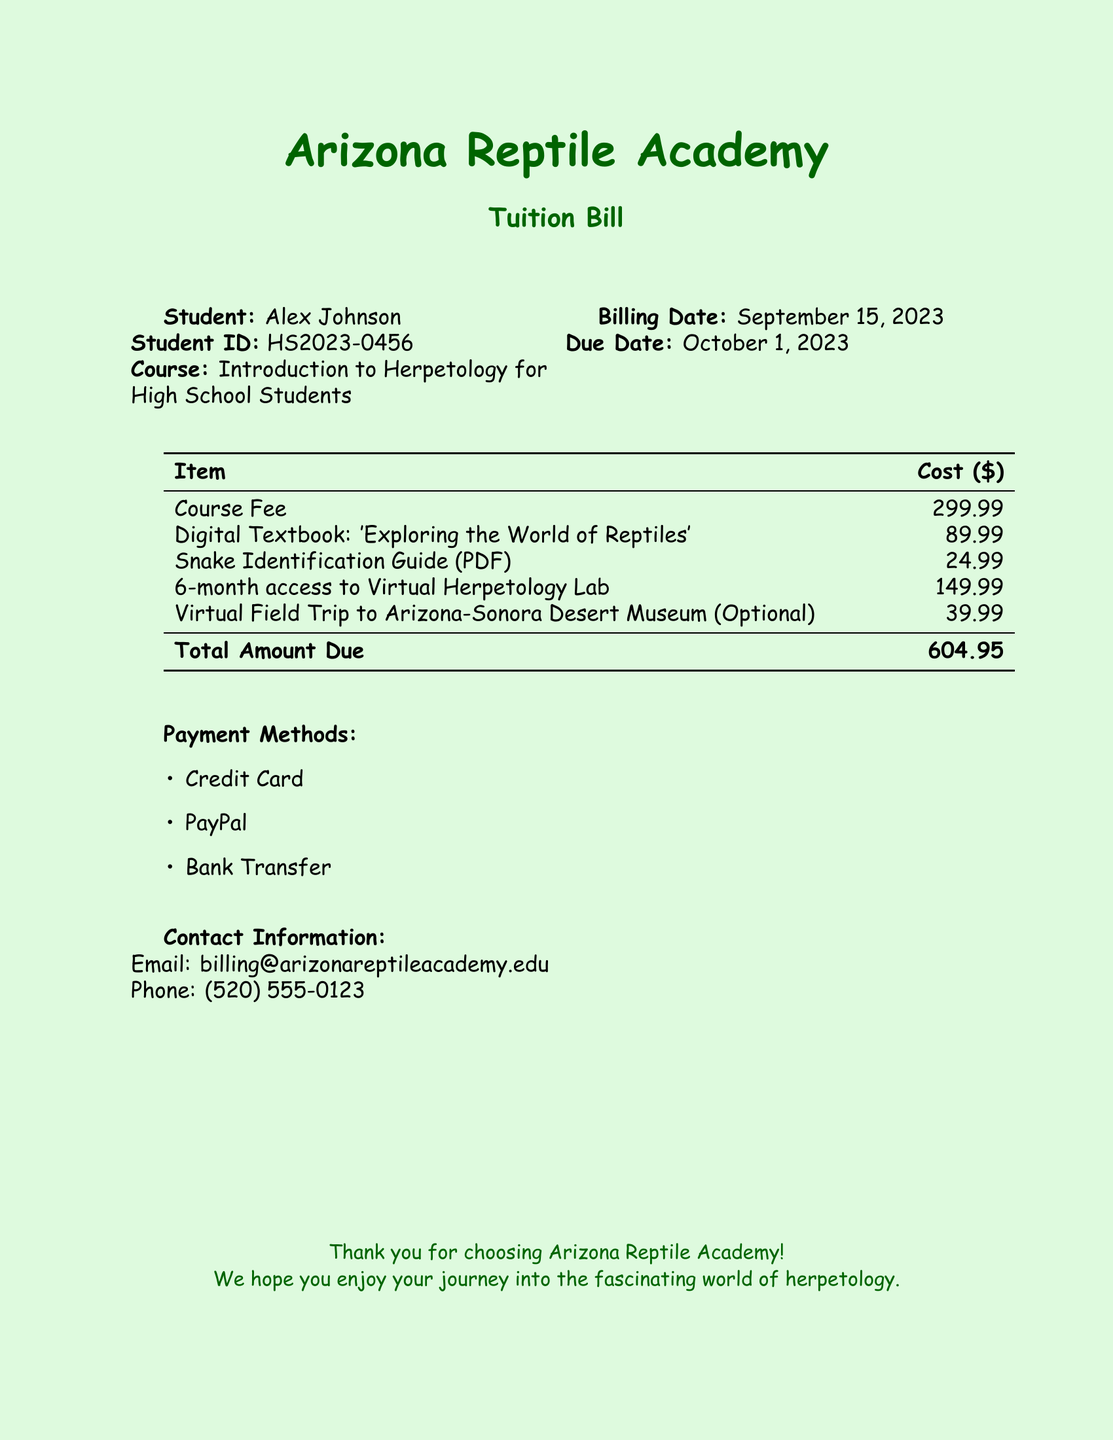What is the student's name? The student's name is listed at the top of the document under "Student."
Answer: Alex Johnson What is the course title? The course title is provided in the document for the herpetology course.
Answer: Introduction to Herpetology for High School Students What is the due date for the tuition bill? The due date is specified in the document under "Due Date."
Answer: October 1, 2023 How much does the virtual field trip cost? The cost of the optional virtual field trip is listed in the table of costs.
Answer: 39.99 What is the total amount due? The total amount due is found at the bottom of the itemized list.
Answer: 604.95 How many months of access does the virtual herpetology lab provide? The document states the duration of access in the description of the lab cost.
Answer: 6-month What payment methods are listed? The payment methods are provided in a bulleted list in the document.
Answer: Credit Card, PayPal, Bank Transfer What is the cost of the digital textbook? The cost of the digital textbook is listed in the table of costs.
Answer: 89.99 How can you contact the billing department? The contact information for billing is given in a separate section at the bottom.
Answer: billing@arizonareptileacademy.edu 